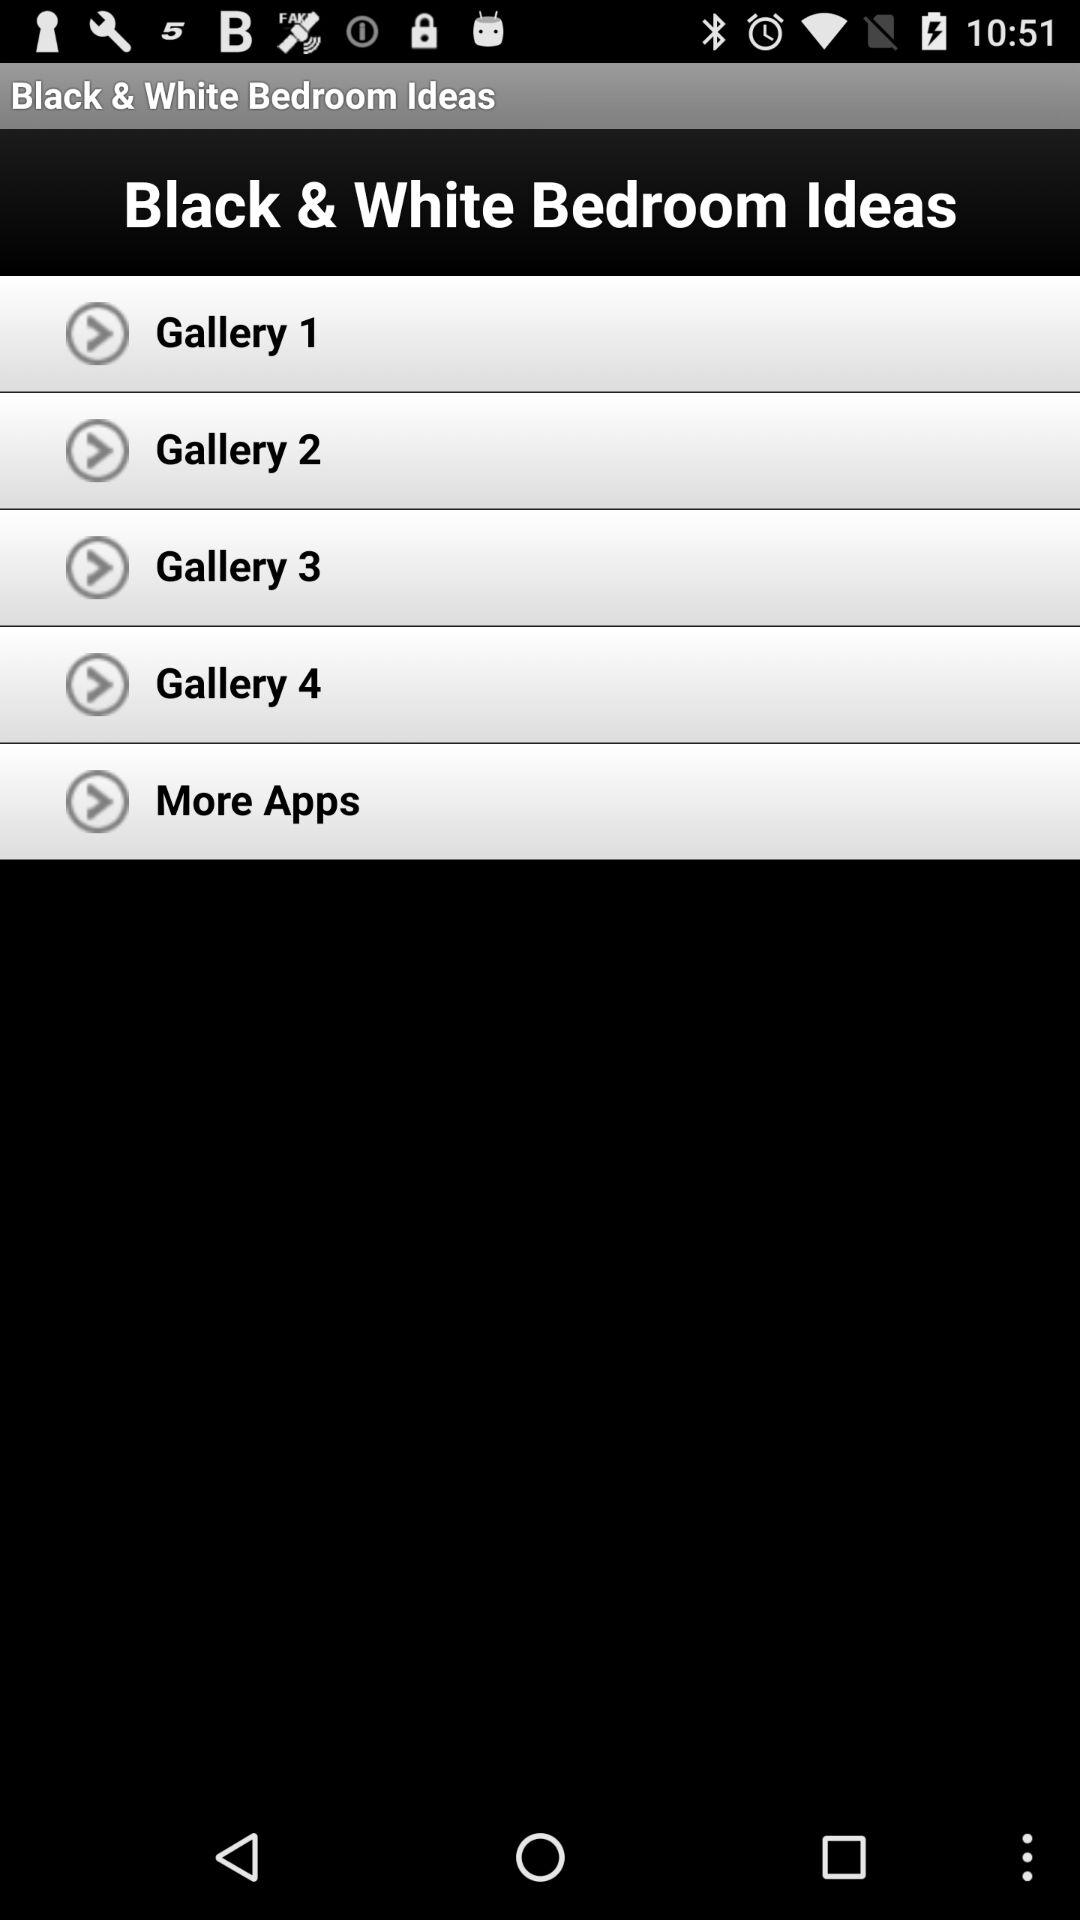How many galleries are displayed before the More Apps item?
Answer the question using a single word or phrase. 4 